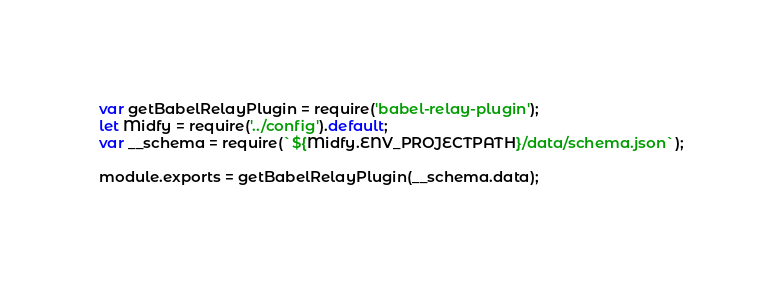Convert code to text. <code><loc_0><loc_0><loc_500><loc_500><_JavaScript_>var getBabelRelayPlugin = require('babel-relay-plugin');
let Midfy = require('../config').default;
var __schema = require(`${Midfy.ENV_PROJECTPATH}/data/schema.json`);

module.exports = getBabelRelayPlugin(__schema.data);</code> 